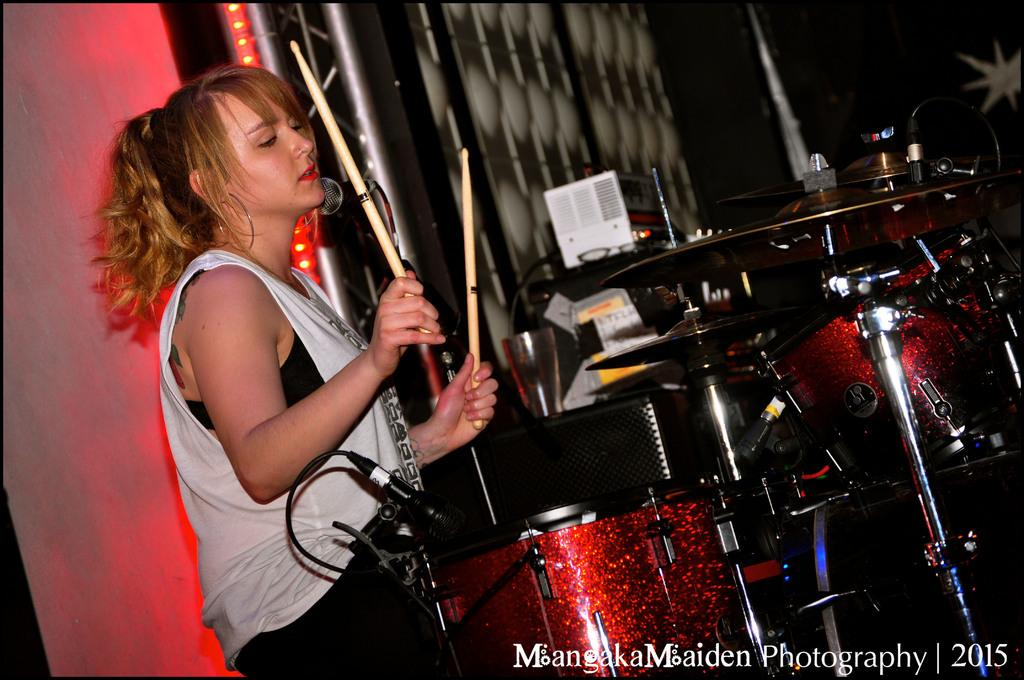Who is the main subject in the image? There is a woman in the image. What is the woman holding in the image? The woman is holding a drumstick. What activity is the woman engaged in? The woman is playing drums. What other percussion instrument is visible in the image? There are cymbals in the image. What device is used for amplifying the woman's voice in the image? There is a microphone in the image. What is the microphone attached to in the image? There is a microphone stand in the image. What can be seen in the background of the image? There are lights and a wall in the background of the image. What type of slope can be seen in the image? There is no slope present in the image. What letters are visible on the drumhead in the image? There are no letters visible on the drumhead in the image. 